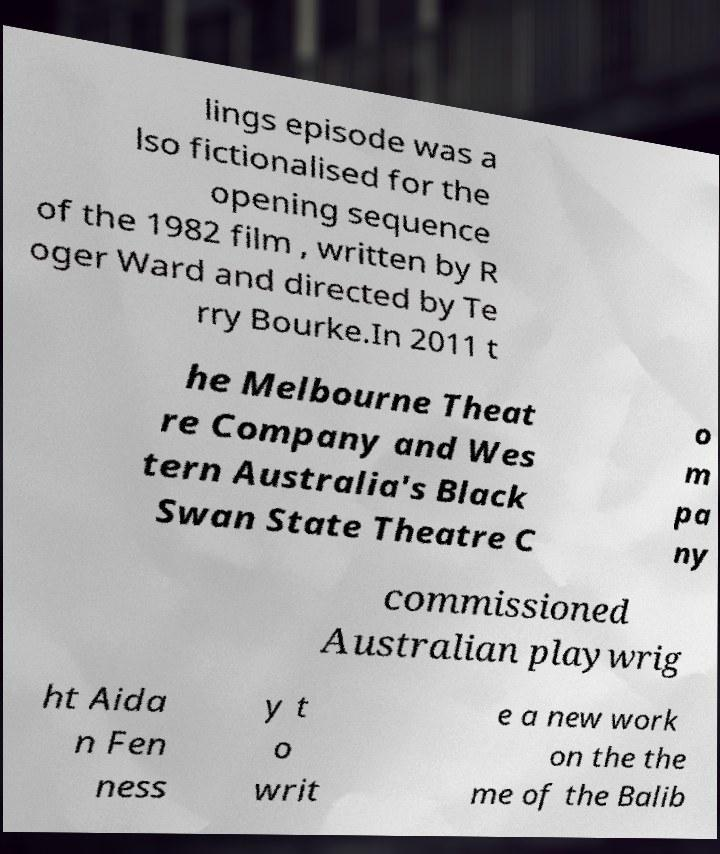Could you assist in decoding the text presented in this image and type it out clearly? lings episode was a lso fictionalised for the opening sequence of the 1982 film , written by R oger Ward and directed by Te rry Bourke.In 2011 t he Melbourne Theat re Company and Wes tern Australia's Black Swan State Theatre C o m pa ny commissioned Australian playwrig ht Aida n Fen ness y t o writ e a new work on the the me of the Balib 